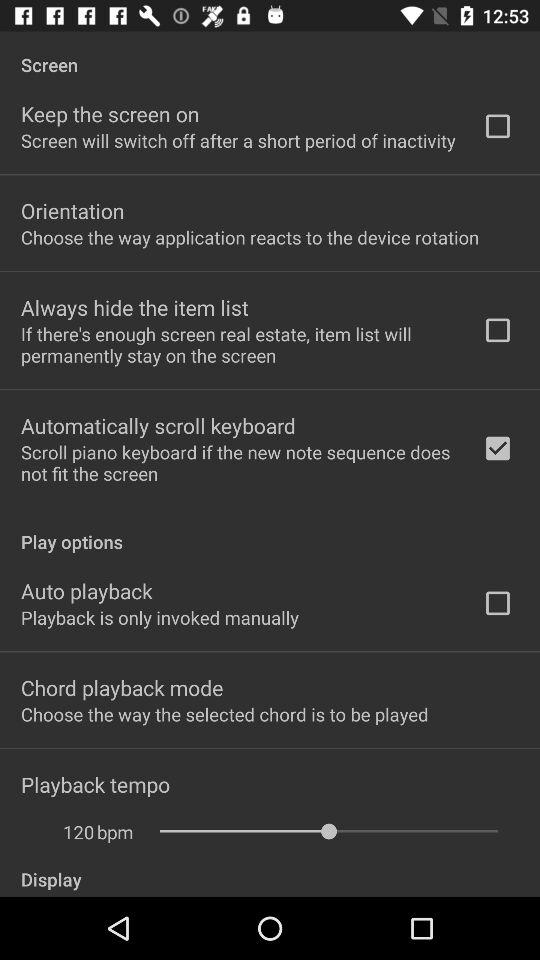What is the selected value of “Playback tempo" in terms of bpm? The selected value of "Playback tempo" is 120 bpm. 